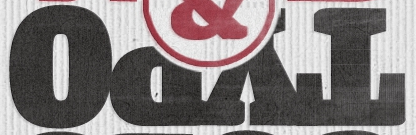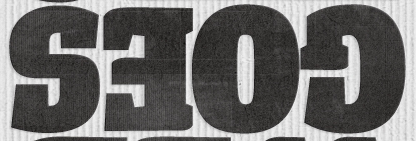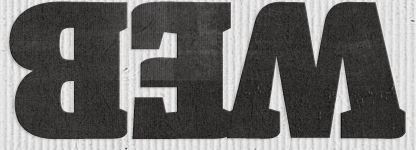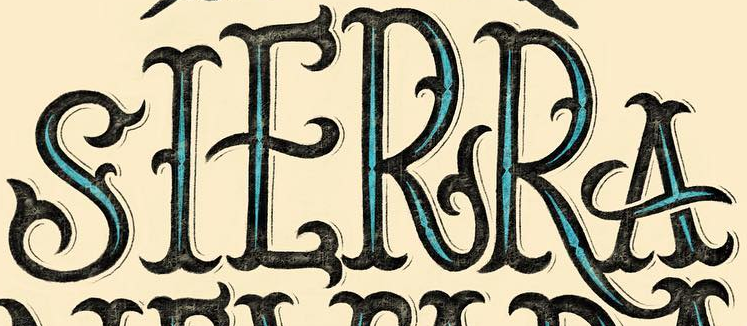Read the text content from these images in order, separated by a semicolon. TYPO; GOES; WEB; SIERRA 